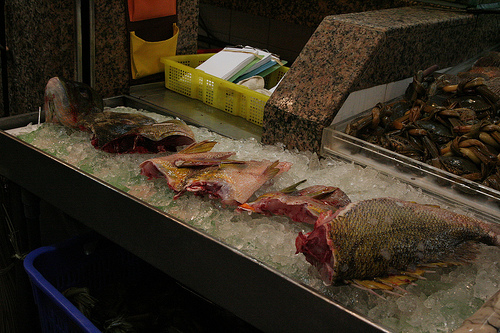<image>
Is there a fish next to the ice? No. The fish is not positioned next to the ice. They are located in different areas of the scene. 